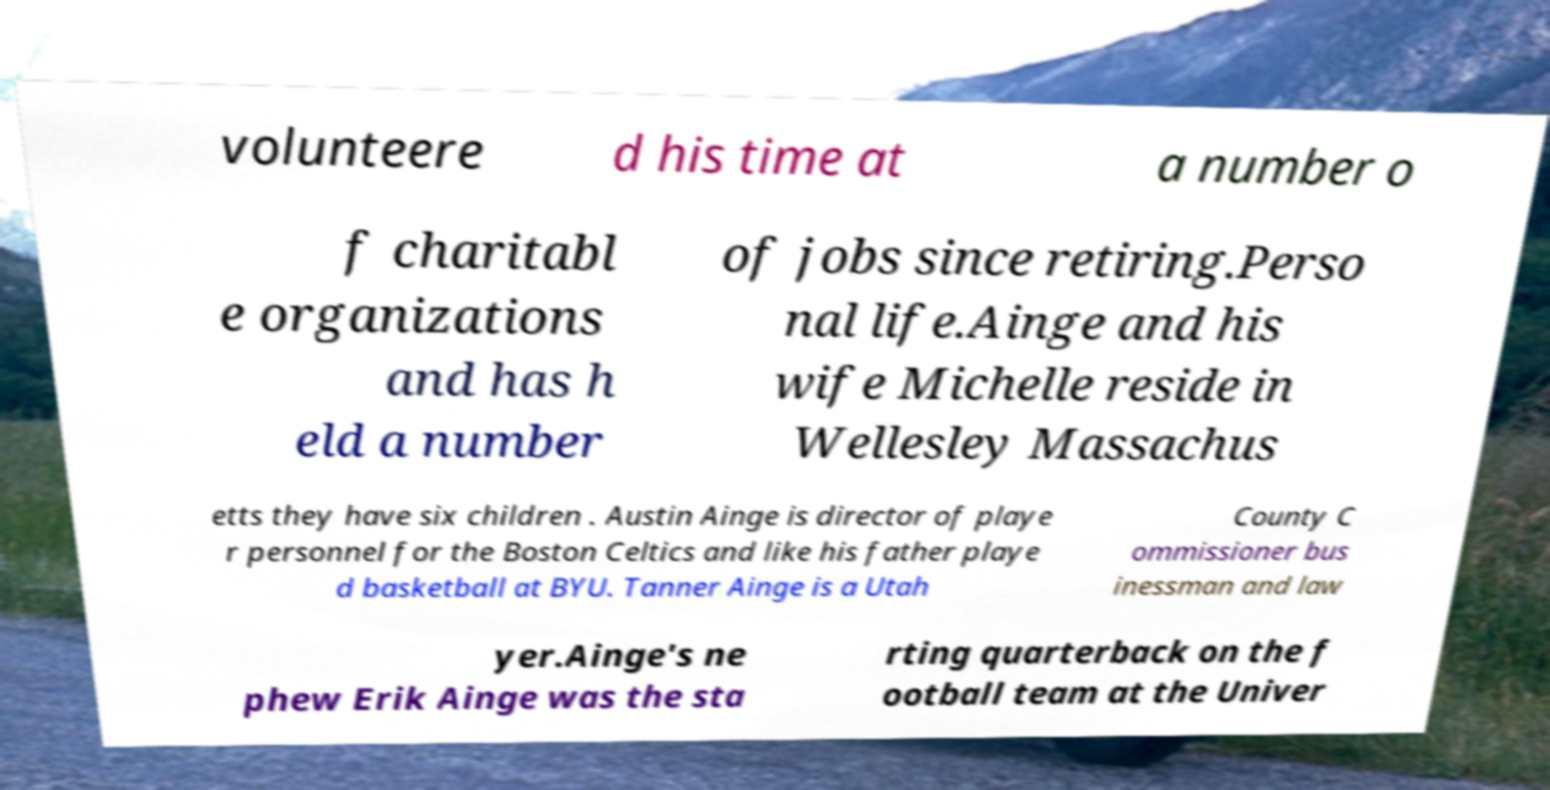Please read and relay the text visible in this image. What does it say? volunteere d his time at a number o f charitabl e organizations and has h eld a number of jobs since retiring.Perso nal life.Ainge and his wife Michelle reside in Wellesley Massachus etts they have six children . Austin Ainge is director of playe r personnel for the Boston Celtics and like his father playe d basketball at BYU. Tanner Ainge is a Utah County C ommissioner bus inessman and law yer.Ainge's ne phew Erik Ainge was the sta rting quarterback on the f ootball team at the Univer 